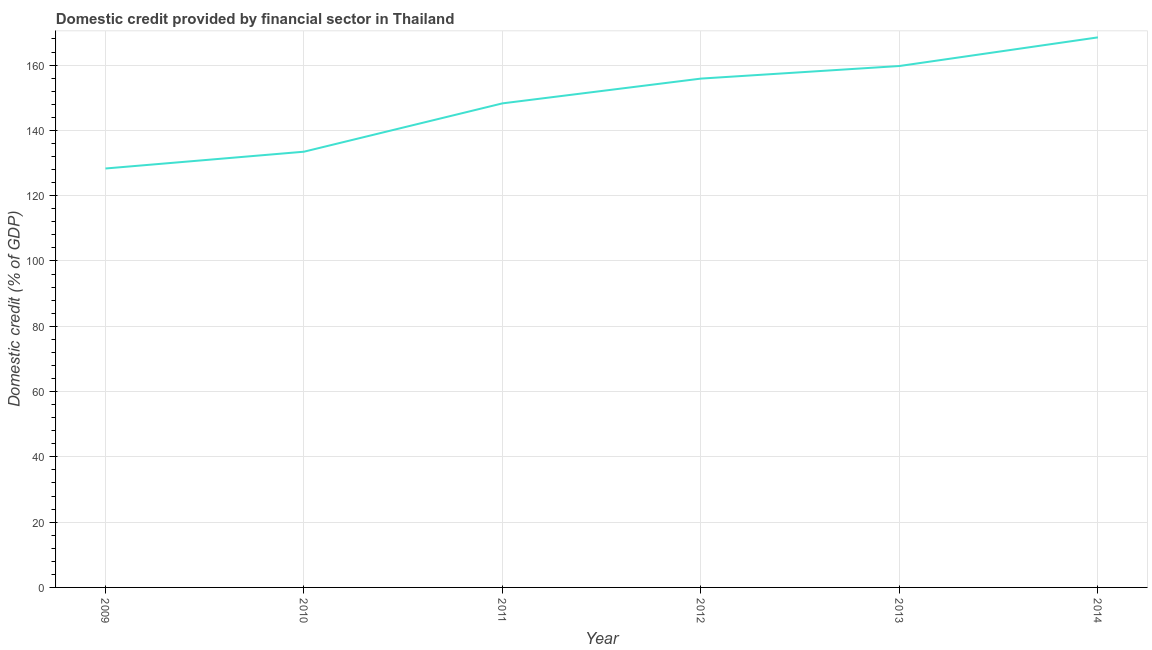What is the domestic credit provided by financial sector in 2010?
Your answer should be compact. 133.46. Across all years, what is the maximum domestic credit provided by financial sector?
Offer a very short reply. 168.48. Across all years, what is the minimum domestic credit provided by financial sector?
Give a very brief answer. 128.32. In which year was the domestic credit provided by financial sector maximum?
Ensure brevity in your answer.  2014. In which year was the domestic credit provided by financial sector minimum?
Provide a short and direct response. 2009. What is the sum of the domestic credit provided by financial sector?
Give a very brief answer. 894.11. What is the difference between the domestic credit provided by financial sector in 2009 and 2012?
Offer a very short reply. -27.54. What is the average domestic credit provided by financial sector per year?
Your response must be concise. 149.02. What is the median domestic credit provided by financial sector?
Offer a very short reply. 152.06. In how many years, is the domestic credit provided by financial sector greater than 40 %?
Offer a very short reply. 6. What is the ratio of the domestic credit provided by financial sector in 2011 to that in 2012?
Give a very brief answer. 0.95. Is the domestic credit provided by financial sector in 2010 less than that in 2011?
Your answer should be very brief. Yes. Is the difference between the domestic credit provided by financial sector in 2010 and 2013 greater than the difference between any two years?
Your response must be concise. No. What is the difference between the highest and the second highest domestic credit provided by financial sector?
Provide a short and direct response. 8.77. What is the difference between the highest and the lowest domestic credit provided by financial sector?
Give a very brief answer. 40.16. How many lines are there?
Ensure brevity in your answer.  1. How many years are there in the graph?
Your response must be concise. 6. What is the difference between two consecutive major ticks on the Y-axis?
Keep it short and to the point. 20. Are the values on the major ticks of Y-axis written in scientific E-notation?
Your answer should be very brief. No. What is the title of the graph?
Your response must be concise. Domestic credit provided by financial sector in Thailand. What is the label or title of the X-axis?
Give a very brief answer. Year. What is the label or title of the Y-axis?
Your answer should be compact. Domestic credit (% of GDP). What is the Domestic credit (% of GDP) of 2009?
Make the answer very short. 128.32. What is the Domestic credit (% of GDP) in 2010?
Give a very brief answer. 133.46. What is the Domestic credit (% of GDP) in 2011?
Make the answer very short. 148.27. What is the Domestic credit (% of GDP) of 2012?
Your answer should be very brief. 155.86. What is the Domestic credit (% of GDP) of 2013?
Make the answer very short. 159.71. What is the Domestic credit (% of GDP) in 2014?
Provide a succinct answer. 168.48. What is the difference between the Domestic credit (% of GDP) in 2009 and 2010?
Offer a very short reply. -5.14. What is the difference between the Domestic credit (% of GDP) in 2009 and 2011?
Offer a terse response. -19.95. What is the difference between the Domestic credit (% of GDP) in 2009 and 2012?
Your answer should be very brief. -27.54. What is the difference between the Domestic credit (% of GDP) in 2009 and 2013?
Offer a terse response. -31.39. What is the difference between the Domestic credit (% of GDP) in 2009 and 2014?
Provide a short and direct response. -40.16. What is the difference between the Domestic credit (% of GDP) in 2010 and 2011?
Offer a very short reply. -14.8. What is the difference between the Domestic credit (% of GDP) in 2010 and 2012?
Offer a terse response. -22.39. What is the difference between the Domestic credit (% of GDP) in 2010 and 2013?
Offer a terse response. -26.25. What is the difference between the Domestic credit (% of GDP) in 2010 and 2014?
Provide a succinct answer. -35.02. What is the difference between the Domestic credit (% of GDP) in 2011 and 2012?
Provide a succinct answer. -7.59. What is the difference between the Domestic credit (% of GDP) in 2011 and 2013?
Keep it short and to the point. -11.44. What is the difference between the Domestic credit (% of GDP) in 2011 and 2014?
Your response must be concise. -20.21. What is the difference between the Domestic credit (% of GDP) in 2012 and 2013?
Keep it short and to the point. -3.86. What is the difference between the Domestic credit (% of GDP) in 2012 and 2014?
Your answer should be compact. -12.63. What is the difference between the Domestic credit (% of GDP) in 2013 and 2014?
Keep it short and to the point. -8.77. What is the ratio of the Domestic credit (% of GDP) in 2009 to that in 2010?
Your response must be concise. 0.96. What is the ratio of the Domestic credit (% of GDP) in 2009 to that in 2011?
Offer a very short reply. 0.86. What is the ratio of the Domestic credit (% of GDP) in 2009 to that in 2012?
Ensure brevity in your answer.  0.82. What is the ratio of the Domestic credit (% of GDP) in 2009 to that in 2013?
Your response must be concise. 0.8. What is the ratio of the Domestic credit (% of GDP) in 2009 to that in 2014?
Offer a very short reply. 0.76. What is the ratio of the Domestic credit (% of GDP) in 2010 to that in 2012?
Offer a terse response. 0.86. What is the ratio of the Domestic credit (% of GDP) in 2010 to that in 2013?
Offer a terse response. 0.84. What is the ratio of the Domestic credit (% of GDP) in 2010 to that in 2014?
Keep it short and to the point. 0.79. What is the ratio of the Domestic credit (% of GDP) in 2011 to that in 2012?
Provide a short and direct response. 0.95. What is the ratio of the Domestic credit (% of GDP) in 2011 to that in 2013?
Your answer should be very brief. 0.93. What is the ratio of the Domestic credit (% of GDP) in 2012 to that in 2014?
Offer a very short reply. 0.93. What is the ratio of the Domestic credit (% of GDP) in 2013 to that in 2014?
Your answer should be compact. 0.95. 